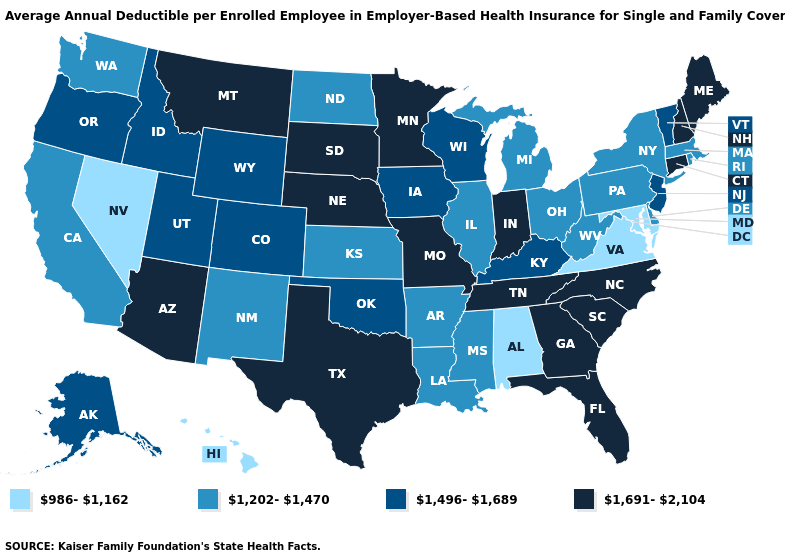Does Nebraska have the lowest value in the MidWest?
Write a very short answer. No. What is the highest value in the South ?
Give a very brief answer. 1,691-2,104. What is the highest value in states that border New Mexico?
Give a very brief answer. 1,691-2,104. What is the value of Maine?
Short answer required. 1,691-2,104. Name the states that have a value in the range 1,202-1,470?
Concise answer only. Arkansas, California, Delaware, Illinois, Kansas, Louisiana, Massachusetts, Michigan, Mississippi, New Mexico, New York, North Dakota, Ohio, Pennsylvania, Rhode Island, Washington, West Virginia. Name the states that have a value in the range 1,202-1,470?
Be succinct. Arkansas, California, Delaware, Illinois, Kansas, Louisiana, Massachusetts, Michigan, Mississippi, New Mexico, New York, North Dakota, Ohio, Pennsylvania, Rhode Island, Washington, West Virginia. Name the states that have a value in the range 1,691-2,104?
Short answer required. Arizona, Connecticut, Florida, Georgia, Indiana, Maine, Minnesota, Missouri, Montana, Nebraska, New Hampshire, North Carolina, South Carolina, South Dakota, Tennessee, Texas. Does the first symbol in the legend represent the smallest category?
Write a very short answer. Yes. Name the states that have a value in the range 1,691-2,104?
Concise answer only. Arizona, Connecticut, Florida, Georgia, Indiana, Maine, Minnesota, Missouri, Montana, Nebraska, New Hampshire, North Carolina, South Carolina, South Dakota, Tennessee, Texas. Among the states that border Kansas , which have the lowest value?
Write a very short answer. Colorado, Oklahoma. Name the states that have a value in the range 1,496-1,689?
Answer briefly. Alaska, Colorado, Idaho, Iowa, Kentucky, New Jersey, Oklahoma, Oregon, Utah, Vermont, Wisconsin, Wyoming. Which states have the highest value in the USA?
Quick response, please. Arizona, Connecticut, Florida, Georgia, Indiana, Maine, Minnesota, Missouri, Montana, Nebraska, New Hampshire, North Carolina, South Carolina, South Dakota, Tennessee, Texas. Name the states that have a value in the range 986-1,162?
Short answer required. Alabama, Hawaii, Maryland, Nevada, Virginia. Name the states that have a value in the range 986-1,162?
Keep it brief. Alabama, Hawaii, Maryland, Nevada, Virginia. 